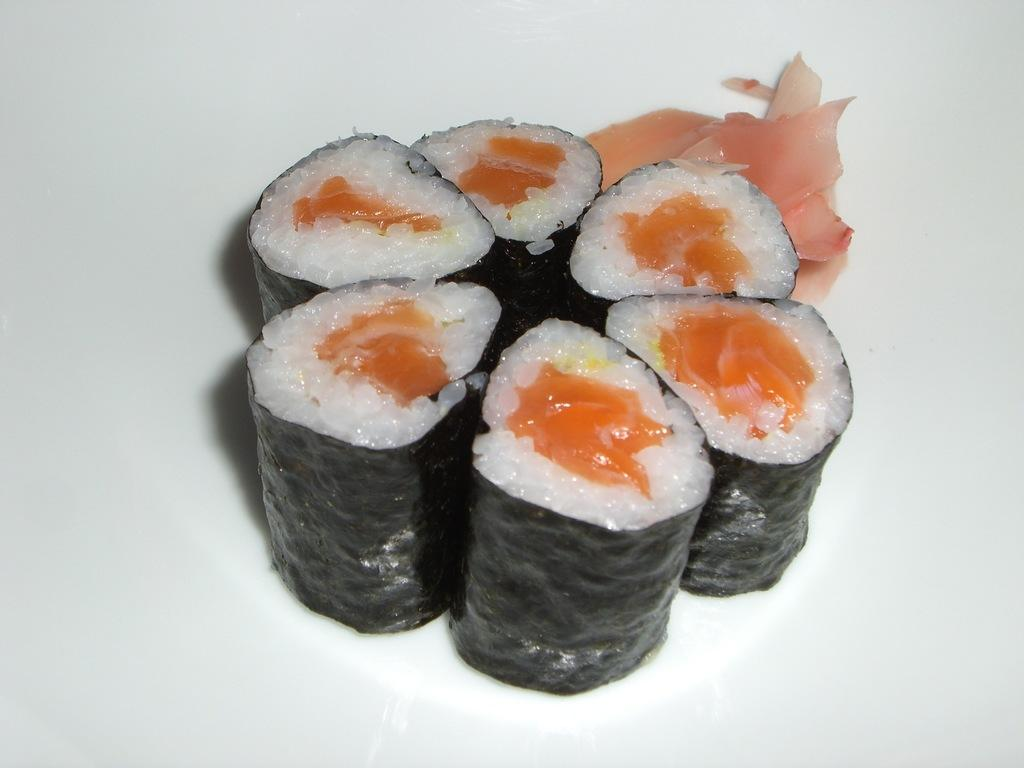What type of food is visible in the image? There is sushi in the image. How is the sushi presented? The sushi is on a white plate. What is inside the sushi? The sushi is stuffed with rice and meat. What type of coat is draped over the sushi in the image? There is no coat present in the image; it features sushi on a white plate. How many snails can be seen crawling on the sushi in the image? There are no snails present in the image; it features sushi on a white plate. 